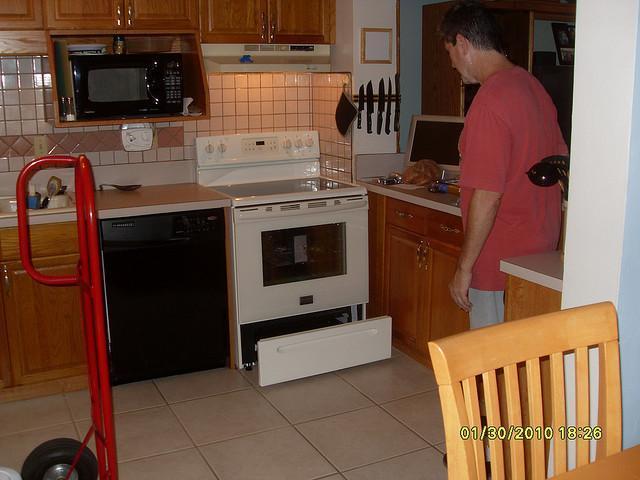How many knives are hanging on the wall?
Give a very brief answer. 5. How many cats are facing away?
Give a very brief answer. 0. 